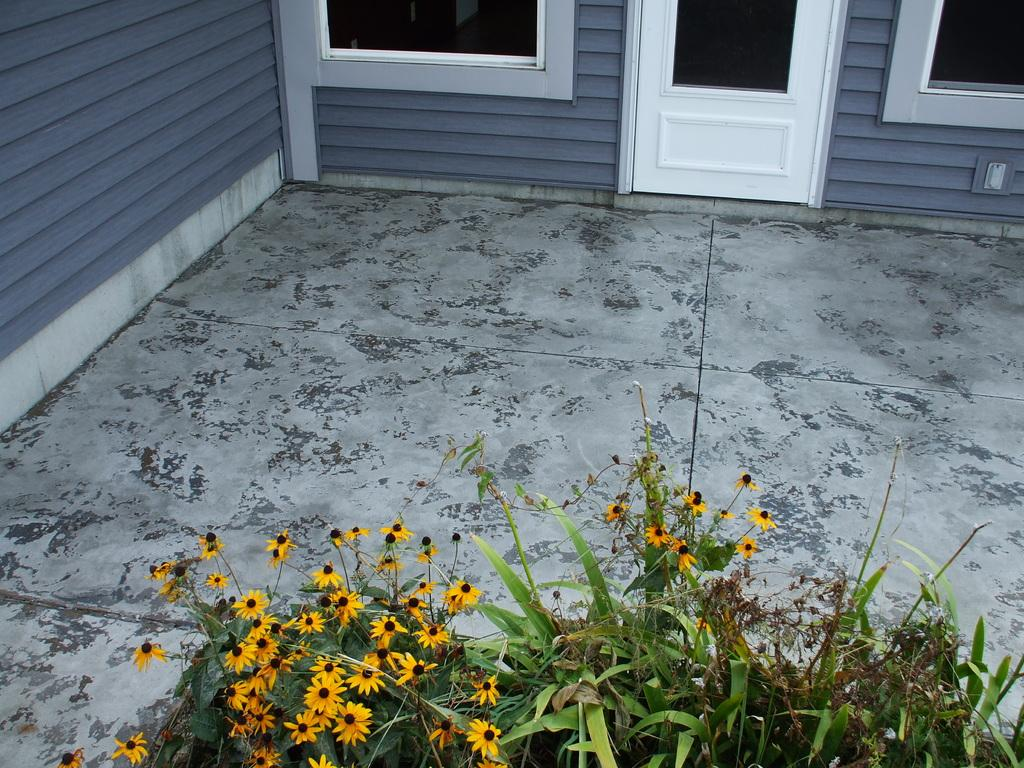What type of living organisms can be seen in the image? Plants can be seen in the image. What color are the flowers on the plants? There are yellow flowers in the image. What architectural feature is visible in the background of the image? There is a door in the background of the image. What color is the door? The door is white. How many glass windows are present in the background of the image? There are two glass windows in the background of the image. What color is the wall in the image? The wall is gray. What nation is represented by the servant standing next to the plants in the image? There is no servant present in the image, so it is not possible to determine which nation they might represent. 